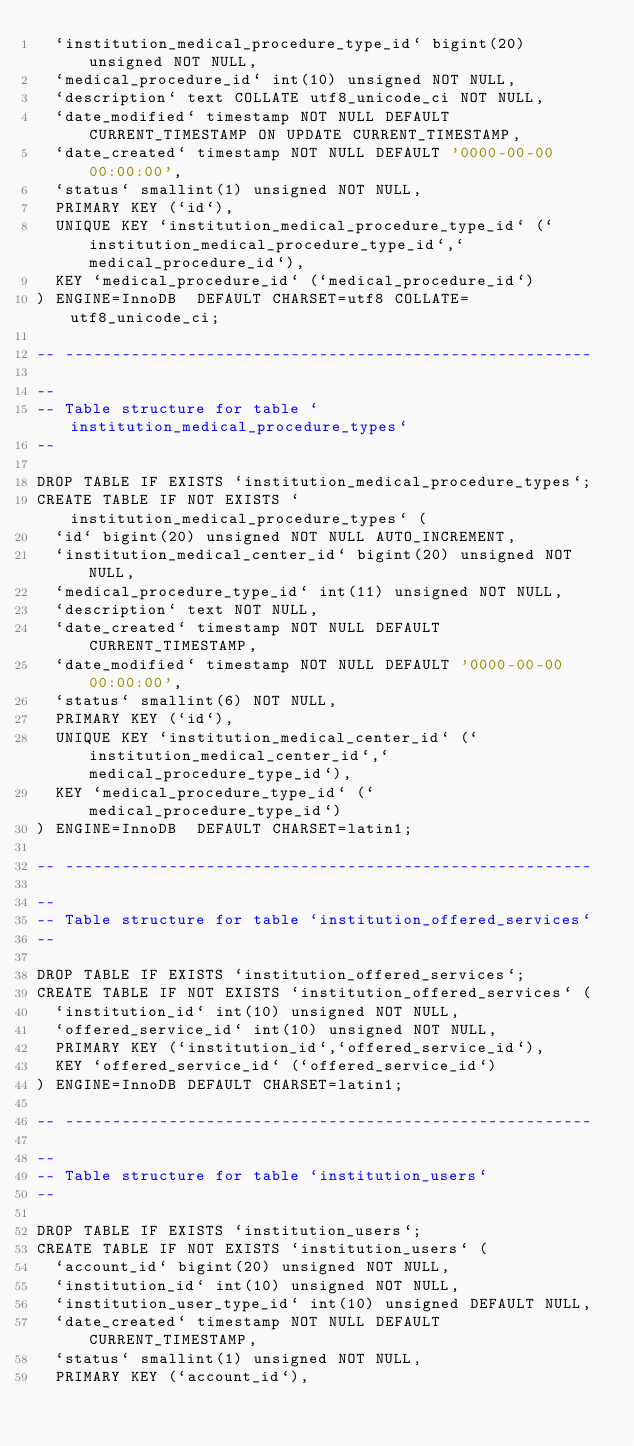Convert code to text. <code><loc_0><loc_0><loc_500><loc_500><_SQL_>  `institution_medical_procedure_type_id` bigint(20) unsigned NOT NULL,
  `medical_procedure_id` int(10) unsigned NOT NULL,
  `description` text COLLATE utf8_unicode_ci NOT NULL,
  `date_modified` timestamp NOT NULL DEFAULT CURRENT_TIMESTAMP ON UPDATE CURRENT_TIMESTAMP,
  `date_created` timestamp NOT NULL DEFAULT '0000-00-00 00:00:00',
  `status` smallint(1) unsigned NOT NULL,
  PRIMARY KEY (`id`),
  UNIQUE KEY `institution_medical_procedure_type_id` (`institution_medical_procedure_type_id`,`medical_procedure_id`),
  KEY `medical_procedure_id` (`medical_procedure_id`)
) ENGINE=InnoDB  DEFAULT CHARSET=utf8 COLLATE=utf8_unicode_ci;

-- --------------------------------------------------------

--
-- Table structure for table `institution_medical_procedure_types`
--

DROP TABLE IF EXISTS `institution_medical_procedure_types`;
CREATE TABLE IF NOT EXISTS `institution_medical_procedure_types` (
  `id` bigint(20) unsigned NOT NULL AUTO_INCREMENT,
  `institution_medical_center_id` bigint(20) unsigned NOT NULL,
  `medical_procedure_type_id` int(11) unsigned NOT NULL,
  `description` text NOT NULL,
  `date_created` timestamp NOT NULL DEFAULT CURRENT_TIMESTAMP,
  `date_modified` timestamp NOT NULL DEFAULT '0000-00-00 00:00:00',
  `status` smallint(6) NOT NULL,
  PRIMARY KEY (`id`),
  UNIQUE KEY `institution_medical_center_id` (`institution_medical_center_id`,`medical_procedure_type_id`),
  KEY `medical_procedure_type_id` (`medical_procedure_type_id`)
) ENGINE=InnoDB  DEFAULT CHARSET=latin1;

-- --------------------------------------------------------

--
-- Table structure for table `institution_offered_services`
--

DROP TABLE IF EXISTS `institution_offered_services`;
CREATE TABLE IF NOT EXISTS `institution_offered_services` (
  `institution_id` int(10) unsigned NOT NULL,
  `offered_service_id` int(10) unsigned NOT NULL,
  PRIMARY KEY (`institution_id`,`offered_service_id`),
  KEY `offered_service_id` (`offered_service_id`)
) ENGINE=InnoDB DEFAULT CHARSET=latin1;

-- --------------------------------------------------------

--
-- Table structure for table `institution_users`
--

DROP TABLE IF EXISTS `institution_users`;
CREATE TABLE IF NOT EXISTS `institution_users` (
  `account_id` bigint(20) unsigned NOT NULL,
  `institution_id` int(10) unsigned NOT NULL,
  `institution_user_type_id` int(10) unsigned DEFAULT NULL,
  `date_created` timestamp NOT NULL DEFAULT CURRENT_TIMESTAMP,
  `status` smallint(1) unsigned NOT NULL,
  PRIMARY KEY (`account_id`),</code> 